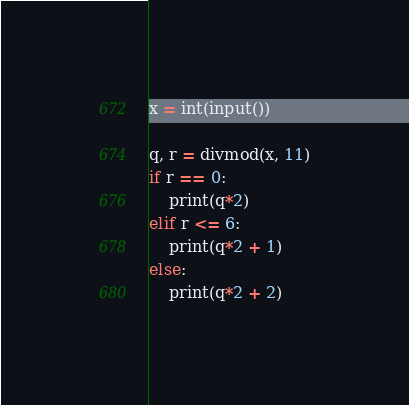Convert code to text. <code><loc_0><loc_0><loc_500><loc_500><_Python_>x = int(input())

q, r = divmod(x, 11)
if r == 0:
    print(q*2)
elif r <= 6:
    print(q*2 + 1)
else:
    print(q*2 + 2)</code> 